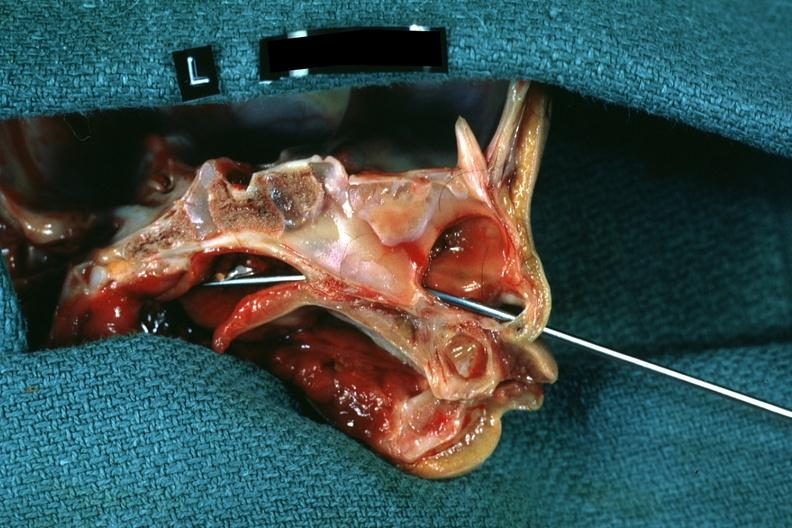was leiomyoma not patent?
Answer the question using a single word or phrase. No 